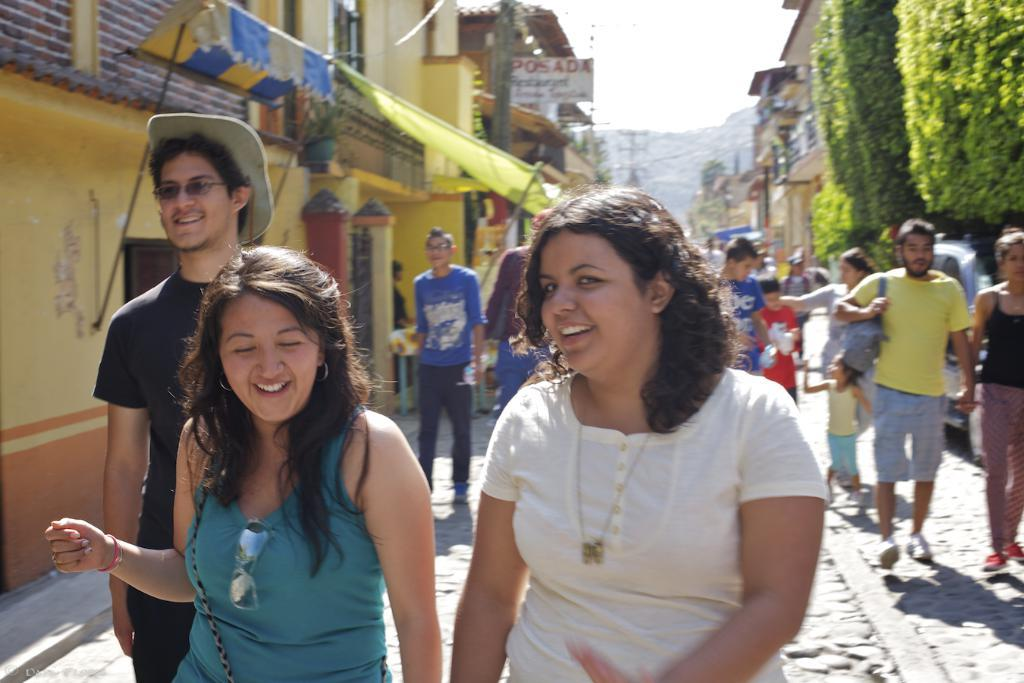What are the people in the image doing? The people in the image are walking. What can be seen in the background of the image? There are buildings, hills, and the sky visible in the background of the image. What type of vegetation is on the right side of the image? There are trees on the right side of the image. What type of van can be seen driving through the hills in the image? There is no van present in the image; it only features people walking and the mentioned background elements. 